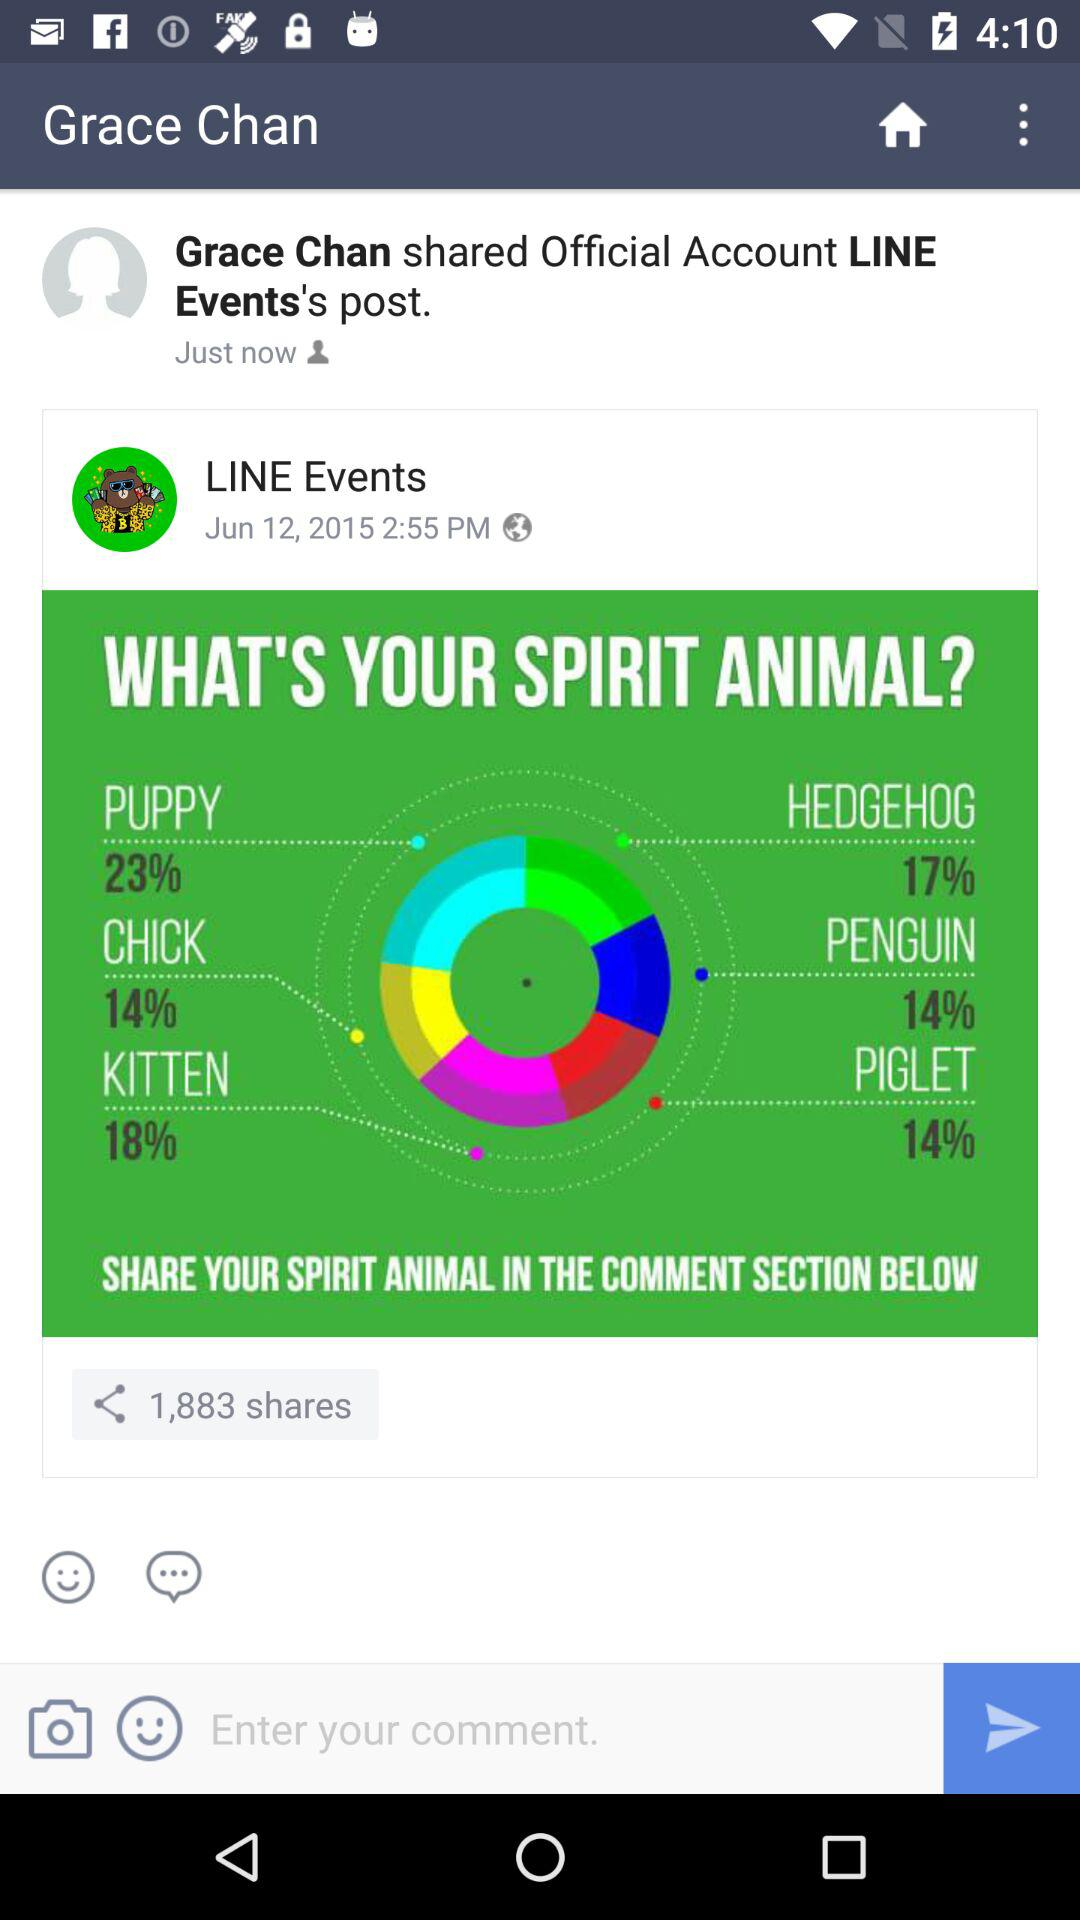What's the user profile name? The user profile name is Grace Chan. 